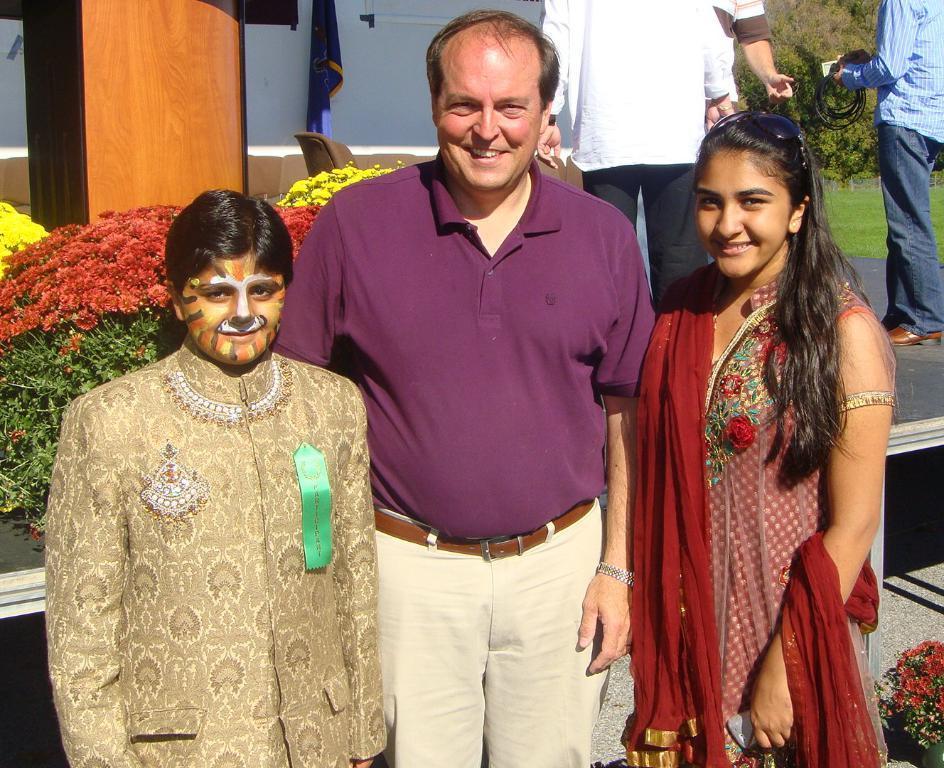Could you give a brief overview of what you see in this image? In the image there are three people standing in the foreground and posing for the photo, behind them there are many flowers and some other people. In the background there is a grass surface and behind the grass surface there are trees. 